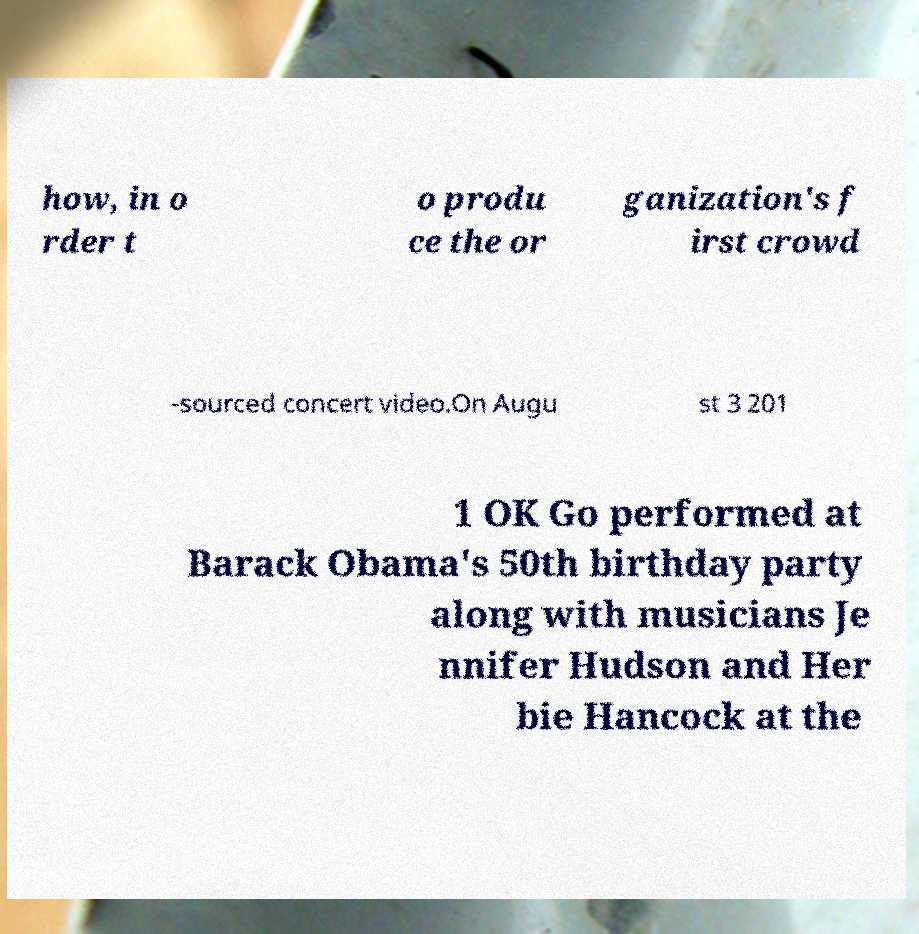For documentation purposes, I need the text within this image transcribed. Could you provide that? how, in o rder t o produ ce the or ganization's f irst crowd -sourced concert video.On Augu st 3 201 1 OK Go performed at Barack Obama's 50th birthday party along with musicians Je nnifer Hudson and Her bie Hancock at the 